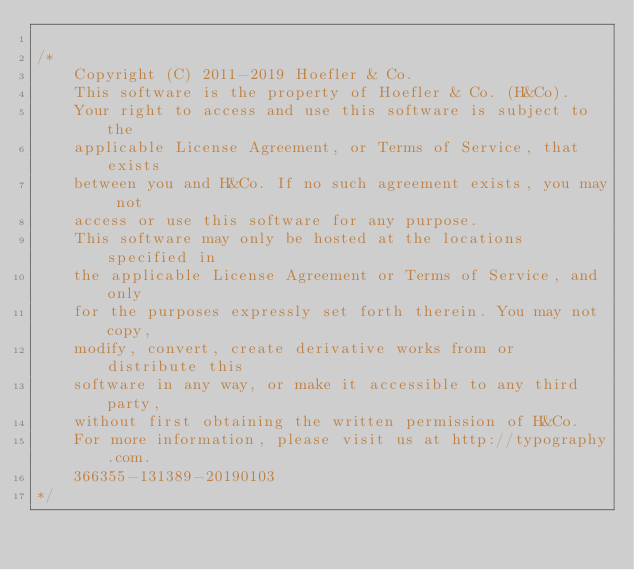Convert code to text. <code><loc_0><loc_0><loc_500><loc_500><_CSS_>
/*
	Copyright (C) 2011-2019 Hoefler & Co.
	This software is the property of Hoefler & Co. (H&Co).
	Your right to access and use this software is subject to the
	applicable License Agreement, or Terms of Service, that exists
	between you and H&Co. If no such agreement exists, you may not
	access or use this software for any purpose.
	This software may only be hosted at the locations specified in
	the applicable License Agreement or Terms of Service, and only
	for the purposes expressly set forth therein. You may not copy,
	modify, convert, create derivative works from or distribute this
	software in any way, or make it accessible to any third party,
	without first obtaining the written permission of H&Co.
	For more information, please visit us at http://typography.com.
	366355-131389-20190103
*/
</code> 